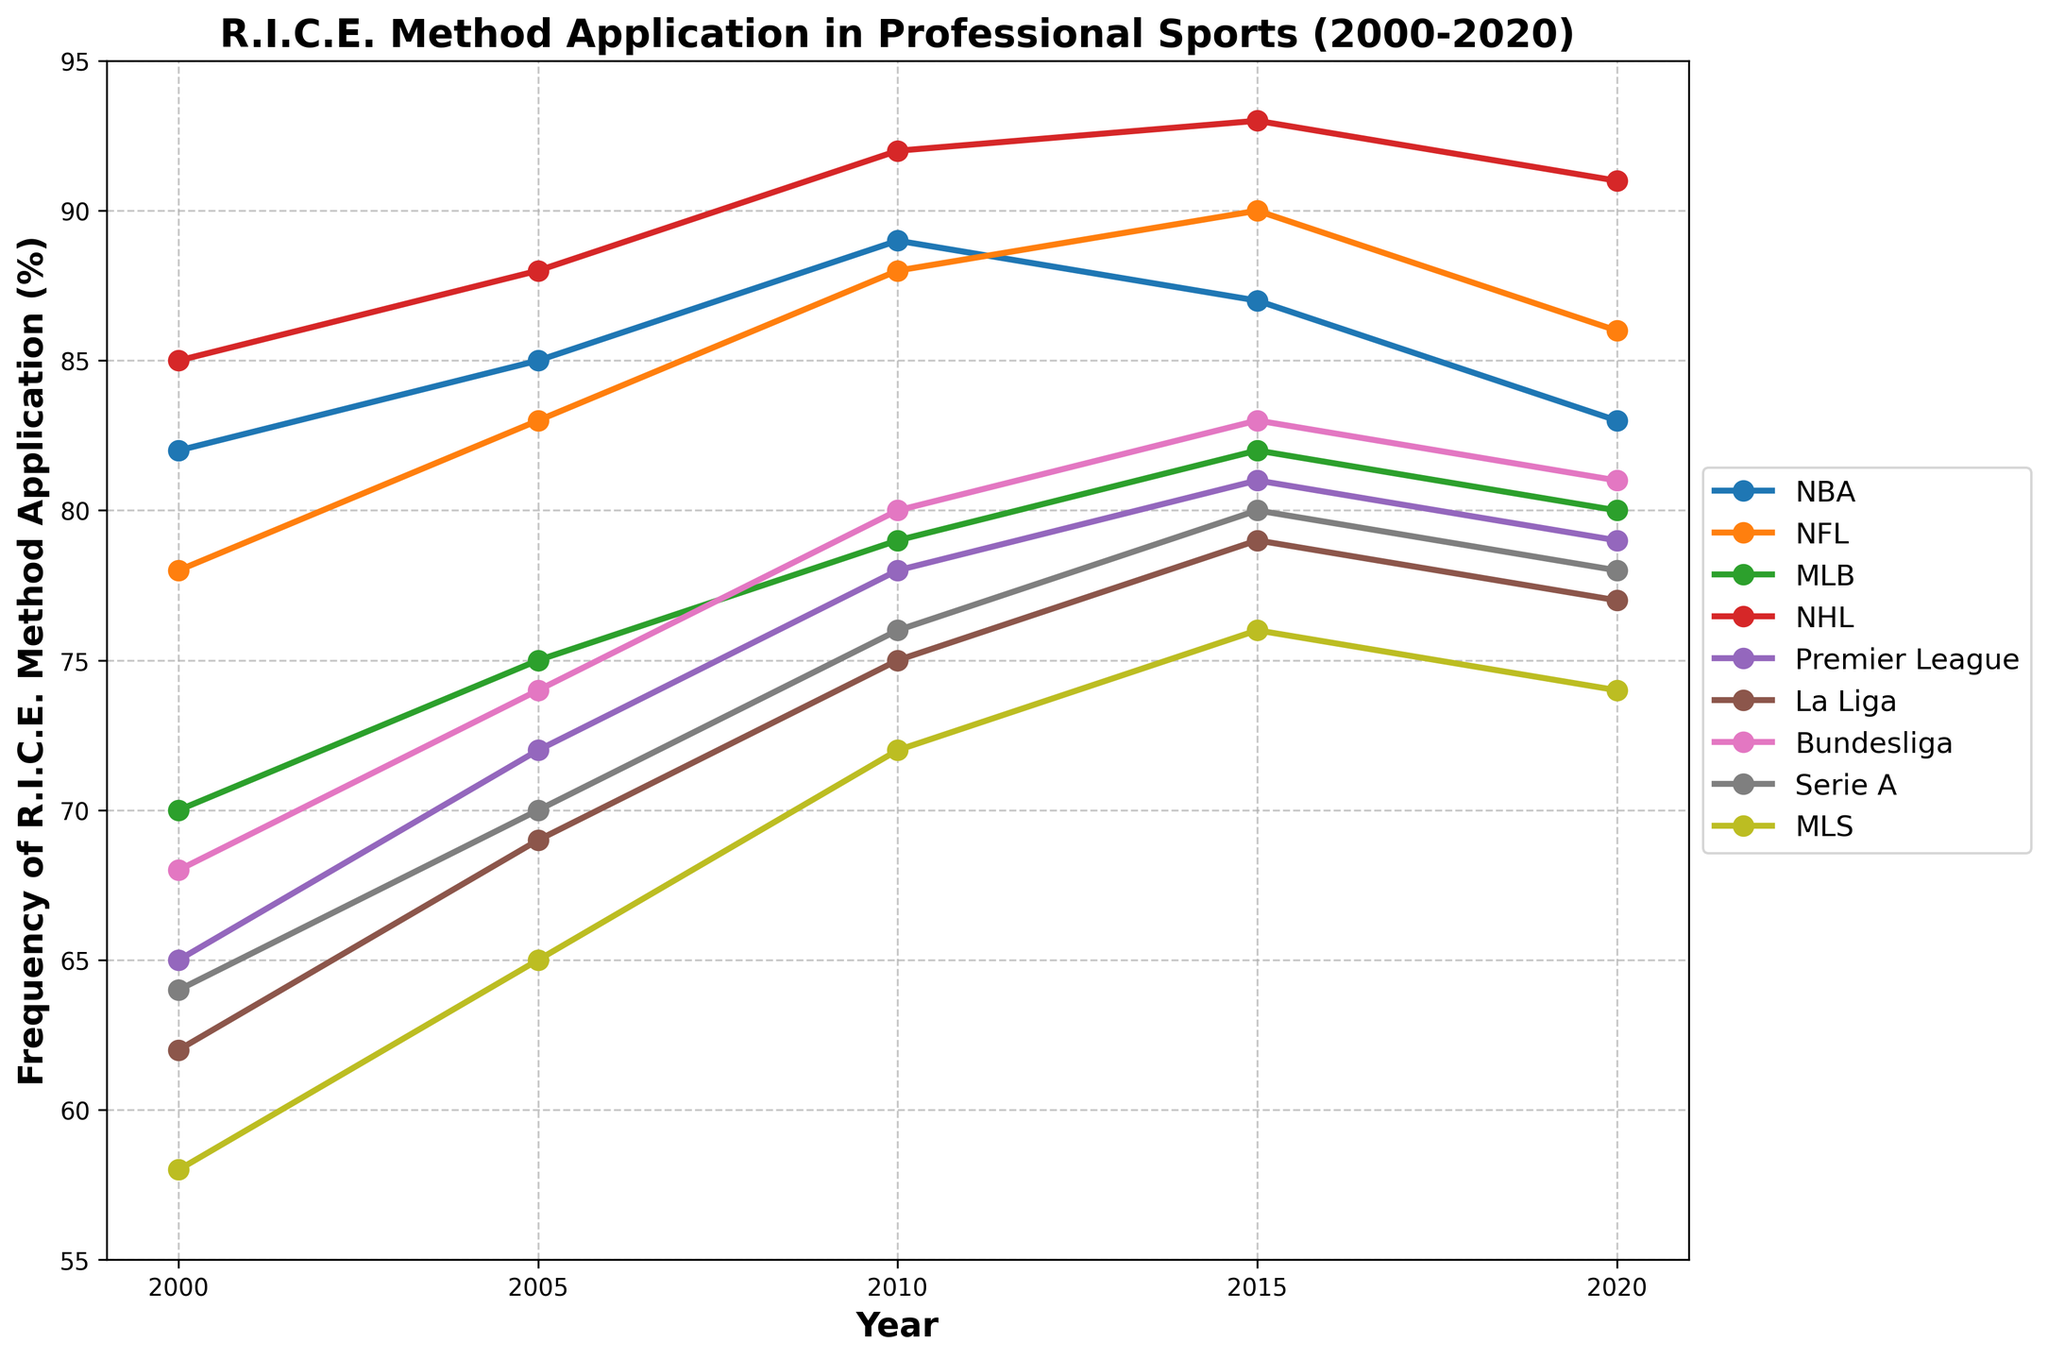What was the overall trend in the frequency of the R.I.C.E. method application in the NBA from 2000 to 2020? Look at the trend line for the NBA. From 2000 to 2010, the frequency increased, reaching a peak in 2010. Then, it had minor fluctuations but generally decreased towards 2020.
Answer: Increasing till 2010, then decreasing How does the change in frequency from 2000 to 2020 in the NHL compare to that in the Premier League? The frequency of R.I.C.E. application in the NHL started at 85% in 2000 and ended at 91% in 2020 (a 6% increase). In the Premier League, it started at 65% and ended at 79% (a 14% increase).
Answer: NHL increased by 6%, Premier League increased by 14% Which league saw the highest application of the R.I.C.E. method in 2020? Check the frequency percentages for each league in 2020. The NHL has the highest value at 91%.
Answer: NHL Between 2000 and 2005, which league experienced the greatest increase in R.I.C.E. method application frequency? Calculate the difference between 2000 and 2005 for each league. The NFL had an increase from 78% to 83%, which is a 5% increase. Other leagues had smaller increases.
Answer: NFL What is the average frequency of R.I.C.E. method application in the MLS and Serie A in 2015? Add the frequencies for MLS and Serie A in 2015, then divide by 2. (76% + 80%) / 2 = 78%.
Answer: 78% Which league had a consistent increase in the application of the R.I.C.E. method over the 20-year period? Look for leagues whose trend lines do not decrease at any point from 2000 to 2020. The NHL and Premier League had a consistent increase throughout the period.
Answer: NHL, Premier League Compare the frequency change in the NFL from 2000 to 2010 with that of Bundesliga over the same period. NFL changed from 78% to 88% (10% increase), Bundesliga changed from 68% to 80% (12% increase).
Answer: NFL 10%, Bundesliga 12% Did any league see a decrease in the frequency of the R.I.C.E. method application from 2015 to 2020? Look at the transition from 2015 to 2020 for each league. NBA (from 87% to 83%) and NFL (from 90% to 86%) saw decreases.
Answer: NBA, NFL 